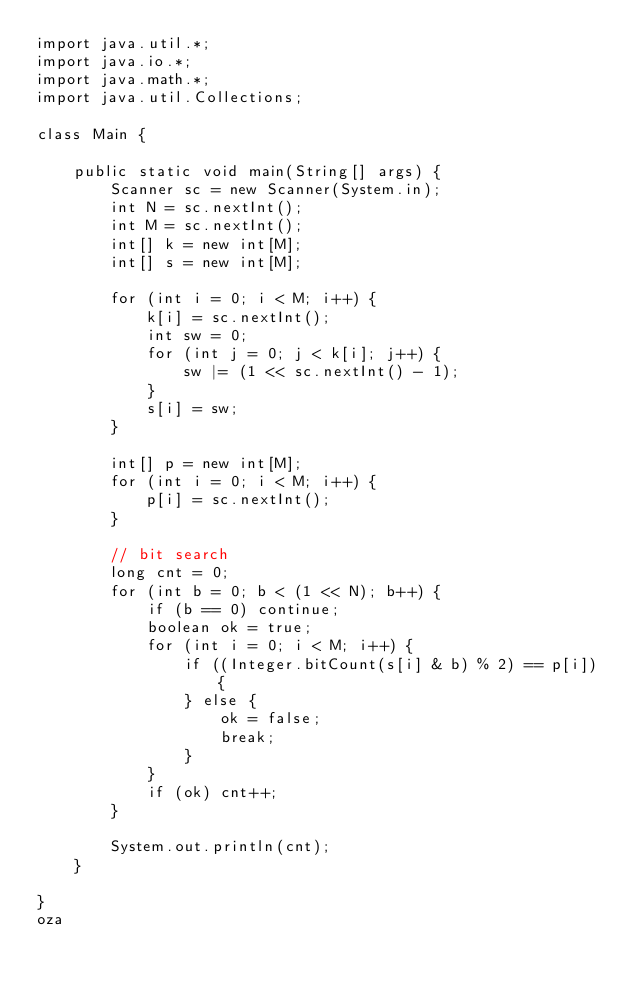Convert code to text. <code><loc_0><loc_0><loc_500><loc_500><_Java_>import java.util.*;
import java.io.*;
import java.math.*;
import java.util.Collections;

class Main {

    public static void main(String[] args) {
        Scanner sc = new Scanner(System.in);
        int N = sc.nextInt();
        int M = sc.nextInt();
        int[] k = new int[M];
        int[] s = new int[M];

        for (int i = 0; i < M; i++) {
            k[i] = sc.nextInt();
            int sw = 0;
            for (int j = 0; j < k[i]; j++) {
                sw |= (1 << sc.nextInt() - 1);
            }
            s[i] = sw;
        }

        int[] p = new int[M];
        for (int i = 0; i < M; i++) {
            p[i] = sc.nextInt();
        }

        // bit search
        long cnt = 0;
        for (int b = 0; b < (1 << N); b++) {
            if (b == 0) continue;
            boolean ok = true;
            for (int i = 0; i < M; i++) {
                if ((Integer.bitCount(s[i] & b) % 2) == p[i]) {
                } else {
                    ok = false;
                    break;
                }
            }
            if (ok) cnt++;
        }

        System.out.println(cnt);
    }

}
oza</code> 